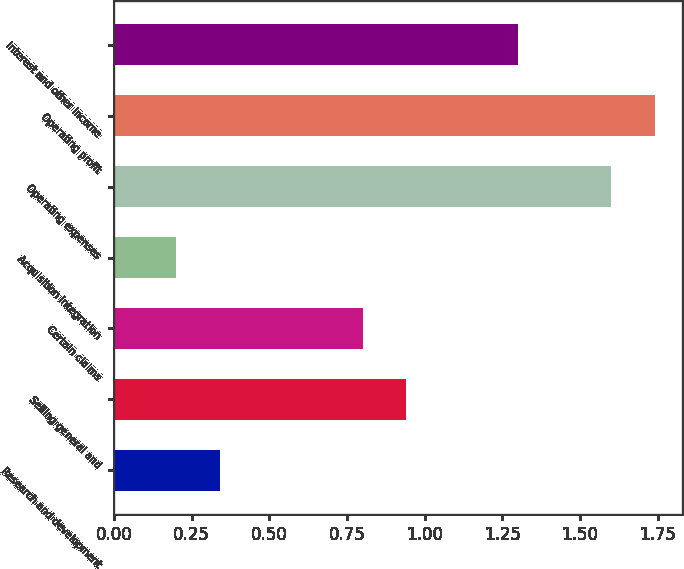Convert chart. <chart><loc_0><loc_0><loc_500><loc_500><bar_chart><fcel>Research and development<fcel>Selling general and<fcel>Certain claims<fcel>Acquisition integration<fcel>Operating expenses<fcel>Operating profit<fcel>Interest and other income<nl><fcel>0.34<fcel>0.94<fcel>0.8<fcel>0.2<fcel>1.6<fcel>1.74<fcel>1.3<nl></chart> 